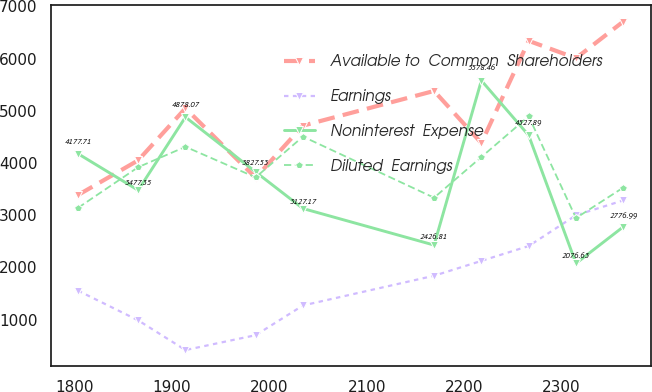Convert chart. <chart><loc_0><loc_0><loc_500><loc_500><line_chart><ecel><fcel>Available to  Common  Shareholders<fcel>Earnings<fcel>Noninterest  Expense<fcel>Diluted  Earnings<nl><fcel>1803.49<fcel>3384.95<fcel>1554.75<fcel>4177.71<fcel>3139.04<nl><fcel>1865.32<fcel>4049.73<fcel>985.45<fcel>3477.35<fcel>3918.72<nl><fcel>1913.89<fcel>5046.9<fcel>416.15<fcel>4878.07<fcel>4309.77<nl><fcel>1985.93<fcel>3717.34<fcel>700.8<fcel>3827.53<fcel>3723.8<nl><fcel>2034.5<fcel>4714.51<fcel>1270.1<fcel>3127.17<fcel>4504.69<nl><fcel>2169.14<fcel>5379.29<fcel>1839.4<fcel>2426.81<fcel>3333.96<nl><fcel>2217.71<fcel>4382.12<fcel>2124.05<fcel>5578.46<fcel>4113.64<nl><fcel>2266.28<fcel>6339.15<fcel>2408.7<fcel>4527.89<fcel>4893.28<nl><fcel>2314.85<fcel>6006.76<fcel>2998.34<fcel>2076.63<fcel>2944.12<nl><fcel>2363.42<fcel>6708.84<fcel>3282.99<fcel>2776.99<fcel>3528.88<nl></chart> 